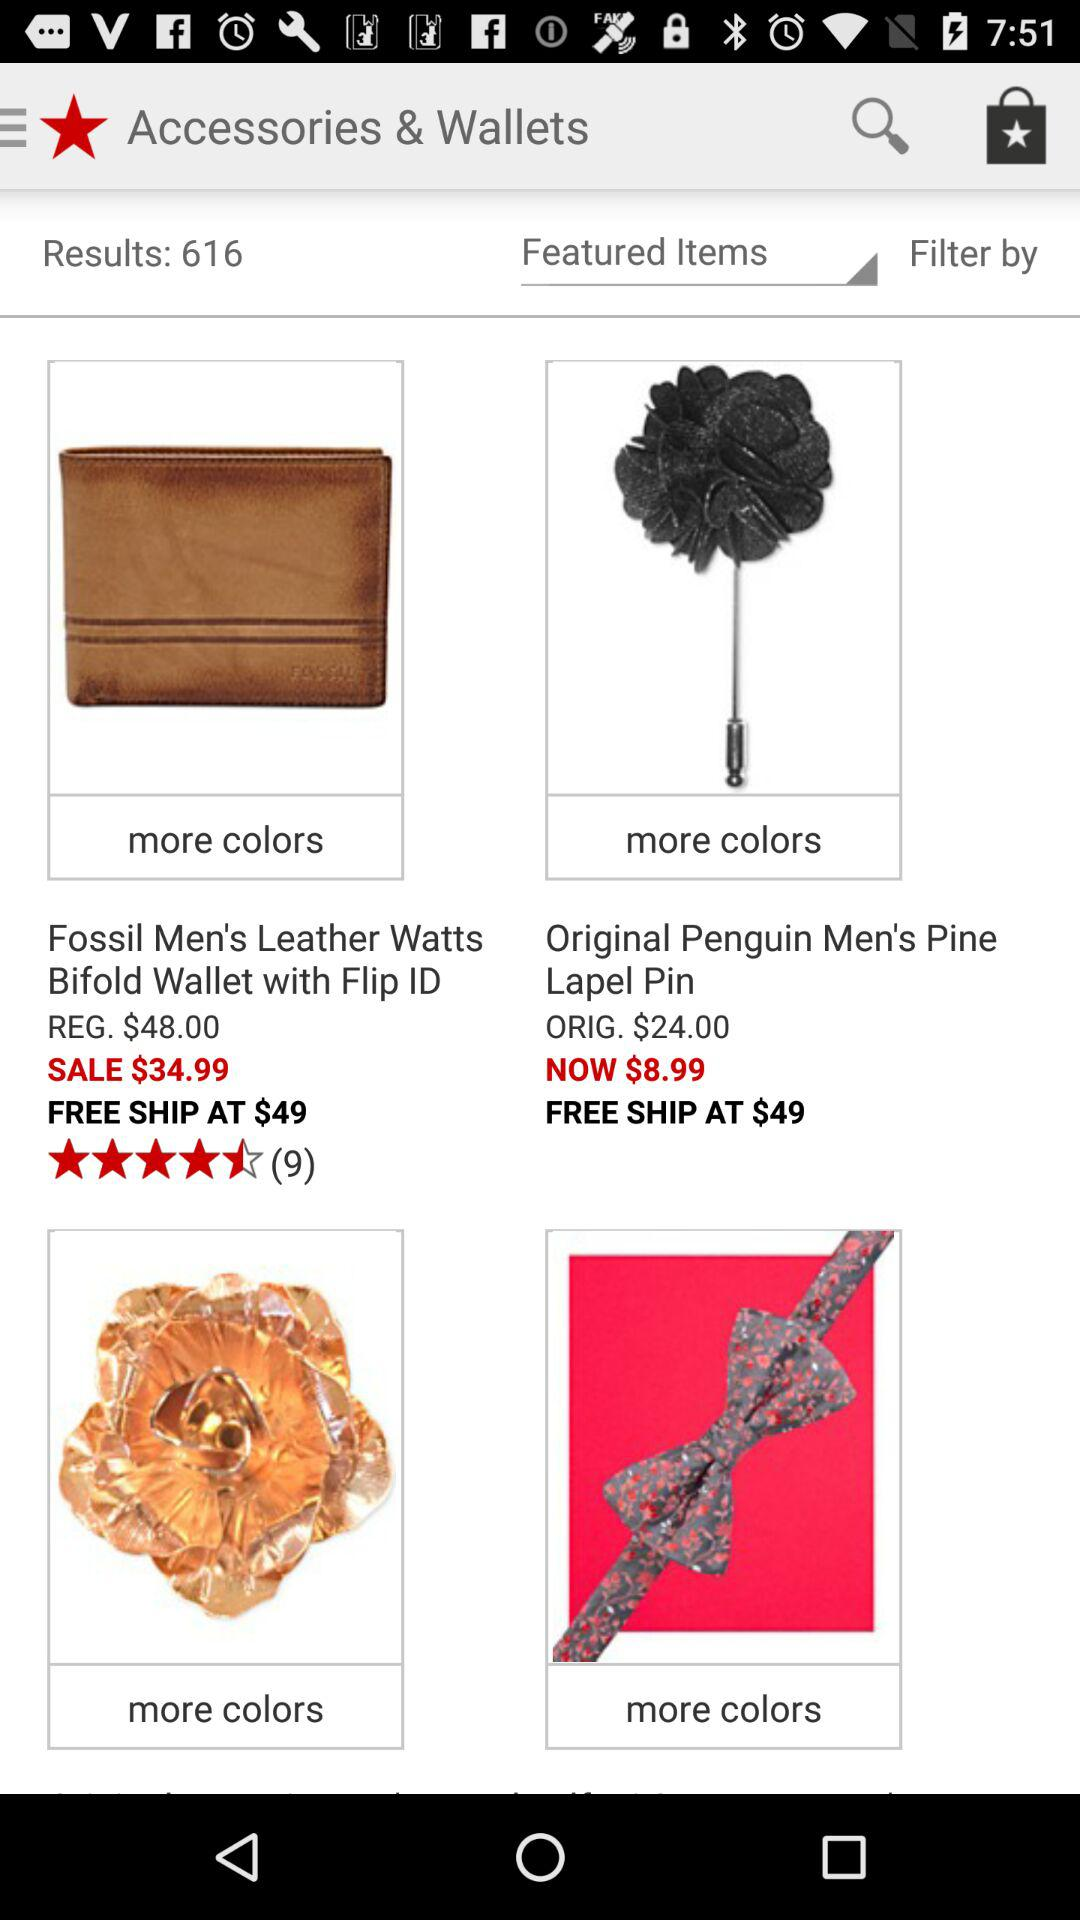What is the number of results? The number of results is 616. 